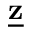<formula> <loc_0><loc_0><loc_500><loc_500>\underline { z }</formula> 